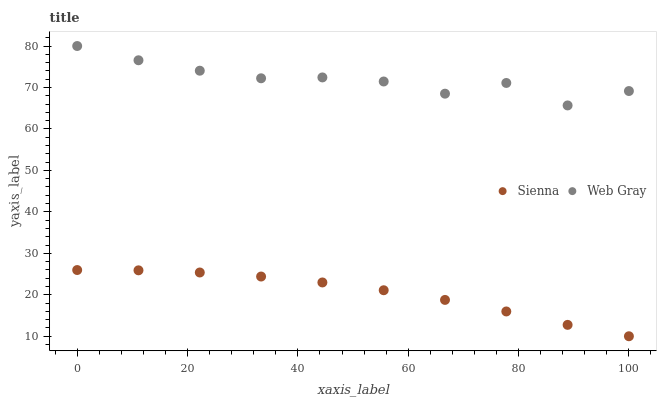Does Sienna have the minimum area under the curve?
Answer yes or no. Yes. Does Web Gray have the maximum area under the curve?
Answer yes or no. Yes. Does Web Gray have the minimum area under the curve?
Answer yes or no. No. Is Sienna the smoothest?
Answer yes or no. Yes. Is Web Gray the roughest?
Answer yes or no. Yes. Is Web Gray the smoothest?
Answer yes or no. No. Does Sienna have the lowest value?
Answer yes or no. Yes. Does Web Gray have the lowest value?
Answer yes or no. No. Does Web Gray have the highest value?
Answer yes or no. Yes. Is Sienna less than Web Gray?
Answer yes or no. Yes. Is Web Gray greater than Sienna?
Answer yes or no. Yes. Does Sienna intersect Web Gray?
Answer yes or no. No. 